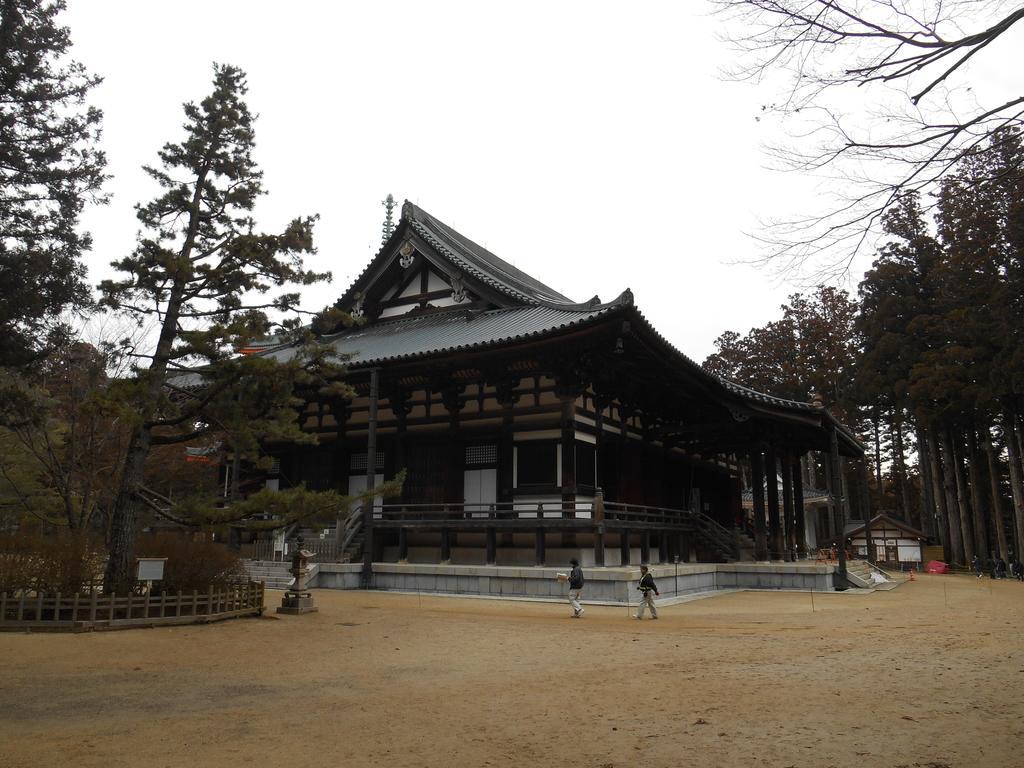How would you summarize this image in a sentence or two? In the center of the image there is a building and persons. On the right side of the image we can see tree. On the left side of the image there are trees. At the bottom there is a ground. In the background we can see sky. 